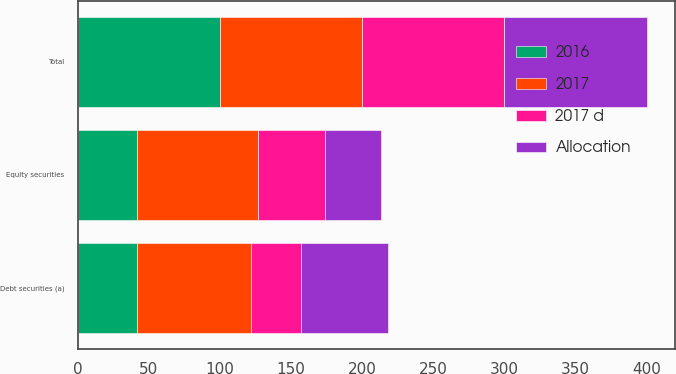Convert chart to OTSL. <chart><loc_0><loc_0><loc_500><loc_500><stacked_bar_chart><ecel><fcel>Debt securities (a)<fcel>Equity securities<fcel>Total<nl><fcel>2017<fcel>80<fcel>85<fcel>100<nl><fcel>2016<fcel>42<fcel>42<fcel>100<nl><fcel>2017 d<fcel>35<fcel>47<fcel>100<nl><fcel>Allocation<fcel>61<fcel>39<fcel>100<nl></chart> 